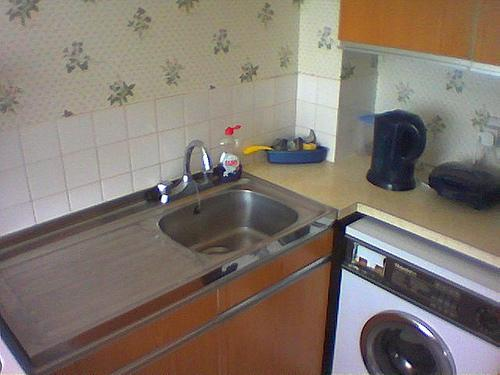Mention one object in the kitchen and its counterpart if any, based on their function. A faucet over the sink and the stainless steel sink, designed for washing dishes and other kitchen tasks. Count the number of flower patterns on the wall and describe their color. There are four flower patterns on the wall, and they have a brownish color. List three primary elements found in the image that are not part of the kitchen setup. Flower design on wallpaper, outlet on the wall, and patterned wallpaper on the wall. How many objects related to dishwashing can be found in the vicinity of the sink, and what are they? There are three objects related to dishwashing near the sink: a bottle of dish soap, a faucet, and a dish with washing scrubbers. Describe how the kitchen appliances are arranged in the image. A black electric tea kettle is placed on the light yellow countertop, and a white washing machine with a control panel is located under the countertop. What is the color and style of the cabinets above and below the countertop? The cabinets above and below the countertop are wooden and brown, featuring a classic design style. What type of tile is on the wall and where is it located? White tiles cover the kitchen wall, particularly above the stainless steel sink. In a single sentence, describe the main theme of the wallpaper. The wallpaper is patterned with a flower design, adding a decorative and warm touch to the room. Is the purple dishwasher located under the wooden cabinets? There is no mention of a purple dishwasher in the image, so it cannot be located anywhere in the image. Do you see the green curtains hanging next to the sink? There is no mention of green curtains in the image, so they cannot be hanging next to the sink. Is there a large red bowl sitting on the countertop? There is no mention of a large red bowl in the image, so it cannot be sitting on the countertop. Can you find the blue fridge on the left side of the kitchen? There is no mention of a blue fridge in the image, so it cannot be found anywhere in the kitchen. Is the pink flower pattern on the wallpaper located near the white washing machine? There are multiple flowers mentioned in the image, but none of them are described as pink, so a pink flower pattern cannot be found near the white washing machine. Can you spot the row of blue tiles along the bottom of the cabinets? There is no mention of blue tiles in the image, so they cannot be found along the bottom of the cabinets. 